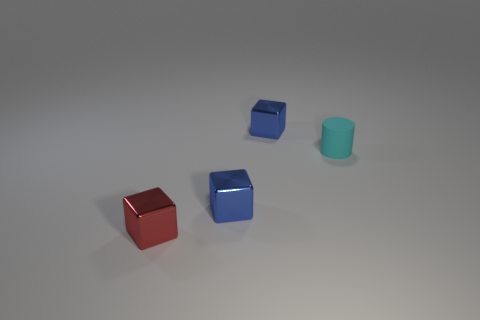Are there any tiny blue blocks that are in front of the small cylinder right of the small blue cube in front of the rubber object?
Keep it short and to the point. Yes. How many balls are tiny metallic things or matte objects?
Provide a succinct answer. 0. How many things are rubber cylinders or cubes?
Your answer should be compact. 4. How many other objects are the same shape as the cyan thing?
Make the answer very short. 0. The shiny object that is behind the red shiny thing and in front of the matte cylinder has what shape?
Provide a short and direct response. Cube. Are there any other things that have the same material as the cyan object?
Your response must be concise. No. Is there anything else of the same color as the small cylinder?
Offer a very short reply. No. Are there more blue objects that are behind the tiny cyan rubber cylinder than large blue rubber cylinders?
Keep it short and to the point. Yes. What material is the cylinder?
Offer a terse response. Rubber. What number of purple blocks are the same size as the red metal cube?
Your answer should be very brief. 0. 